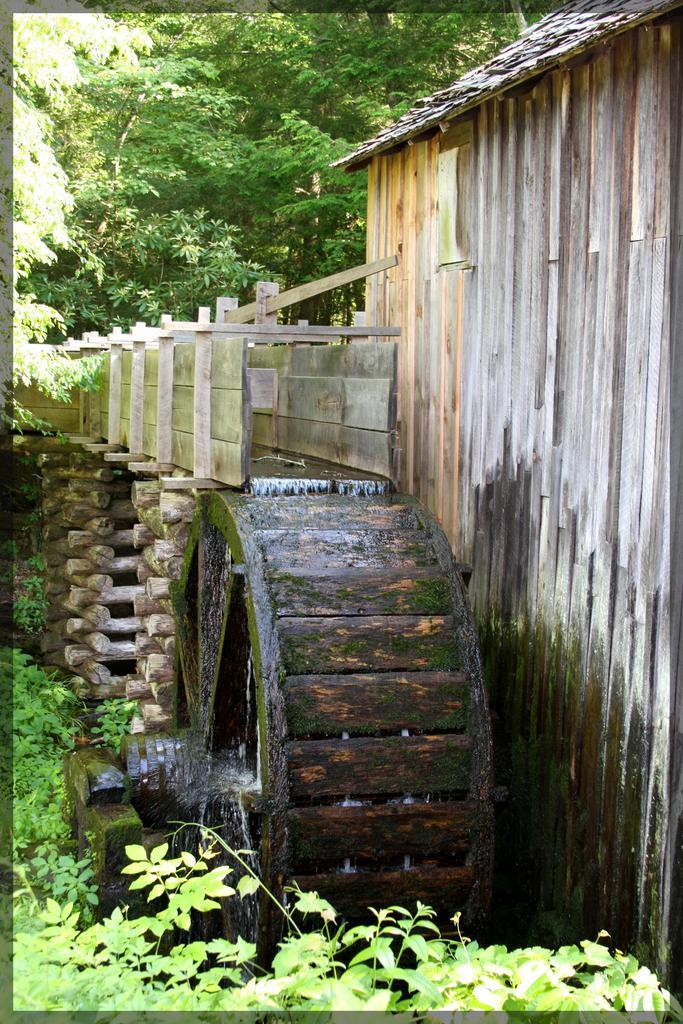Can you describe this image briefly? In the foreground of this image, at the bottom and top, there is greenery. In the middle, there is wooden wall and water flowing onto the wheel. 